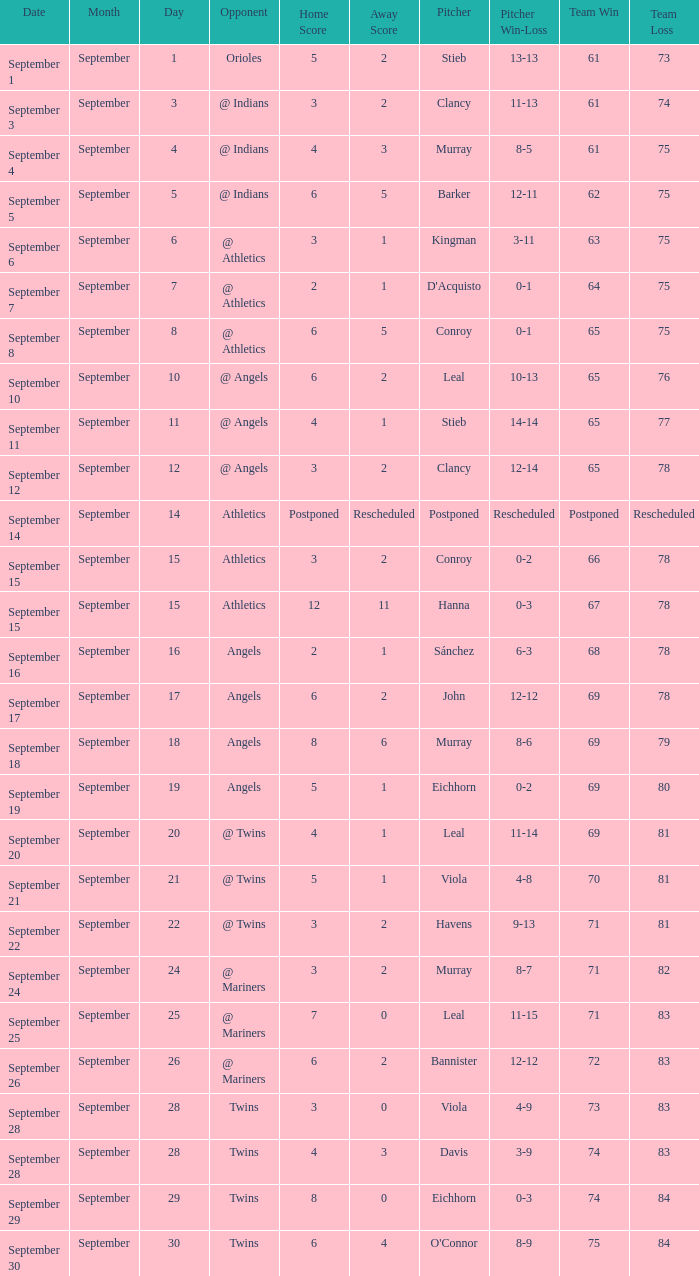Name the score for september 11 4 - 1. Can you give me this table as a dict? {'header': ['Date', 'Month', 'Day', 'Opponent', 'Home Score', 'Away Score', 'Pitcher', 'Pitcher Win-Loss', 'Team Win', 'Team Loss'], 'rows': [['September 1', 'September', '1', 'Orioles', '5', '2', 'Stieb', '13-13', '61', '73'], ['September 3', 'September', '3', '@ Indians', '3', '2', 'Clancy', '11-13', '61', '74'], ['September 4', 'September', '4', '@ Indians', '4', '3', 'Murray', '8-5', '61', '75'], ['September 5', 'September', '5', '@ Indians', '6', '5', 'Barker', '12-11', '62', '75'], ['September 6', 'September', '6', '@ Athletics', '3', '1', 'Kingman', '3-11', '63', '75'], ['September 7', 'September', '7', '@ Athletics', '2', '1', "D'Acquisto", '0-1', '64', '75'], ['September 8', 'September', '8', '@ Athletics', '6', '5', 'Conroy', '0-1', '65', '75'], ['September 10', 'September', '10', '@ Angels', '6', '2', 'Leal', '10-13', '65', '76'], ['September 11', 'September', '11', '@ Angels', '4', '1', 'Stieb', '14-14', '65', '77'], ['September 12', 'September', '12', '@ Angels', '3', '2', 'Clancy', '12-14', '65', '78'], ['September 14', 'September', '14', 'Athletics', 'Postponed', 'Rescheduled', 'Postponed', 'Rescheduled', 'Postponed', 'Rescheduled'], ['September 15', 'September', '15', 'Athletics', '3', '2', 'Conroy', '0-2', '66', '78'], ['September 15', 'September', '15', 'Athletics', '12', '11', 'Hanna', '0-3', '67', '78'], ['September 16', 'September', '16', 'Angels', '2', '1', 'Sánchez', '6-3', '68', '78'], ['September 17', 'September', '17', 'Angels', '6', '2', 'John', '12-12', '69', '78'], ['September 18', 'September', '18', 'Angels', '8', '6', 'Murray', '8-6', '69', '79'], ['September 19', 'September', '19', 'Angels', '5', '1', 'Eichhorn', '0-2', '69', '80'], ['September 20', 'September', '20', '@ Twins', '4', '1', 'Leal', '11-14', '69', '81'], ['September 21', 'September', '21', '@ Twins', '5', '1', 'Viola', '4-8', '70', '81'], ['September 22', 'September', '22', '@ Twins', '3', '2', 'Havens', '9-13', '71', '81'], ['September 24', 'September', '24', '@ Mariners', '3', '2', 'Murray', '8-7', '71', '82'], ['September 25', 'September', '25', '@ Mariners', '7', '0', 'Leal', '11-15', '71', '83'], ['September 26', 'September', '26', '@ Mariners', '6', '2', 'Bannister', '12-12', '72', '83'], ['September 28', 'September', '28', 'Twins', '3', '0', 'Viola', '4-9', '73', '83'], ['September 28', 'September', '28', 'Twins', '4', '3', 'Davis', '3-9', '74', '83'], ['September 29', 'September', '29', 'Twins', '8', '0', 'Eichhorn', '0-3', '74', '84'], ['September 30', 'September', '30', 'Twins', '6', '4', "O'Connor", '8-9', '75', '84']]} 